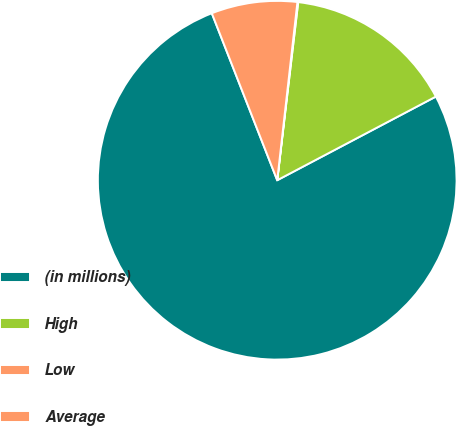<chart> <loc_0><loc_0><loc_500><loc_500><pie_chart><fcel>(in millions)<fcel>High<fcel>Low<fcel>Average<nl><fcel>76.78%<fcel>15.41%<fcel>0.07%<fcel>7.74%<nl></chart> 